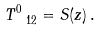Convert formula to latex. <formula><loc_0><loc_0><loc_500><loc_500>T ^ { 0 } _ { \ 1 2 } = S ( z ) \, .</formula> 